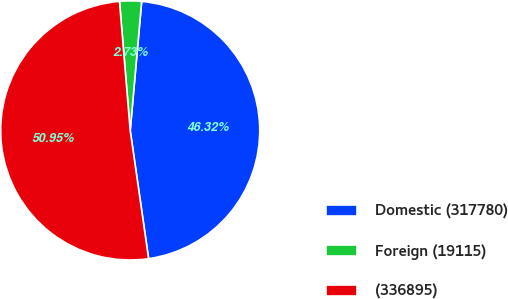Convert chart. <chart><loc_0><loc_0><loc_500><loc_500><pie_chart><fcel>Domestic (317780)<fcel>Foreign (19115)<fcel>(336895)<nl><fcel>46.32%<fcel>2.73%<fcel>50.95%<nl></chart> 